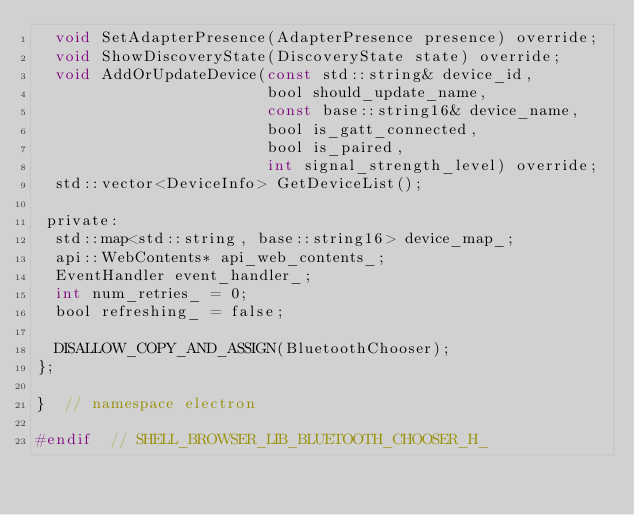<code> <loc_0><loc_0><loc_500><loc_500><_C_>  void SetAdapterPresence(AdapterPresence presence) override;
  void ShowDiscoveryState(DiscoveryState state) override;
  void AddOrUpdateDevice(const std::string& device_id,
                         bool should_update_name,
                         const base::string16& device_name,
                         bool is_gatt_connected,
                         bool is_paired,
                         int signal_strength_level) override;
  std::vector<DeviceInfo> GetDeviceList();

 private:
  std::map<std::string, base::string16> device_map_;
  api::WebContents* api_web_contents_;
  EventHandler event_handler_;
  int num_retries_ = 0;
  bool refreshing_ = false;

  DISALLOW_COPY_AND_ASSIGN(BluetoothChooser);
};

}  // namespace electron

#endif  // SHELL_BROWSER_LIB_BLUETOOTH_CHOOSER_H_
</code> 